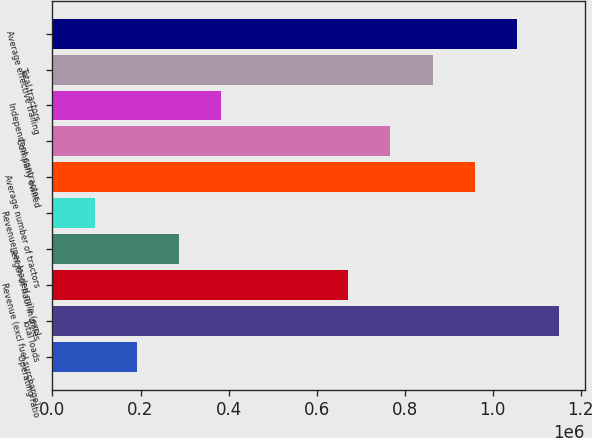Convert chart. <chart><loc_0><loc_0><loc_500><loc_500><bar_chart><fcel>Operating ratio<fcel>Total loads<fcel>Revenue (excl fuel surcharge)<fcel>Length of haul in miles<fcel>Revenue per loaded mile (excl<fcel>Average number of tractors<fcel>Company owned<fcel>Independent contractor<fcel>Total tractors<fcel>Average effective trailing<nl><fcel>191911<fcel>1.15146e+06<fcel>671686<fcel>287866<fcel>95955.7<fcel>959551<fcel>767641<fcel>383821<fcel>863596<fcel>1.05551e+06<nl></chart> 